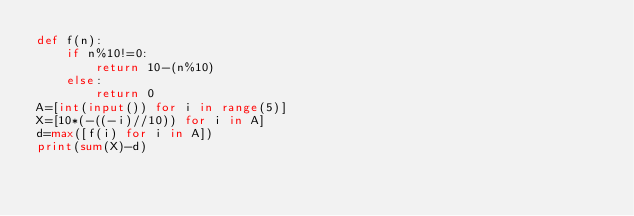Convert code to text. <code><loc_0><loc_0><loc_500><loc_500><_Python_>def f(n):
    if n%10!=0:
        return 10-(n%10)
    else:
        return 0
A=[int(input()) for i in range(5)]
X=[10*(-((-i)//10)) for i in A]
d=max([f(i) for i in A])
print(sum(X)-d)</code> 